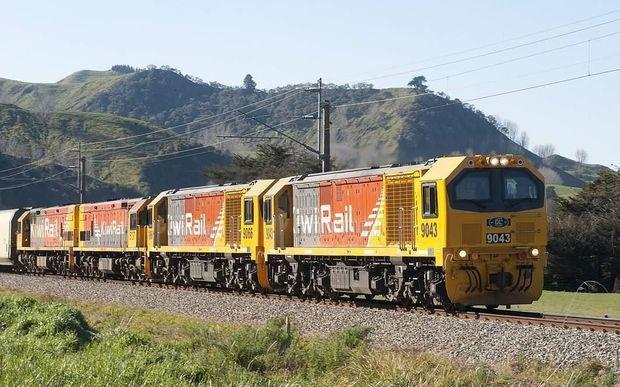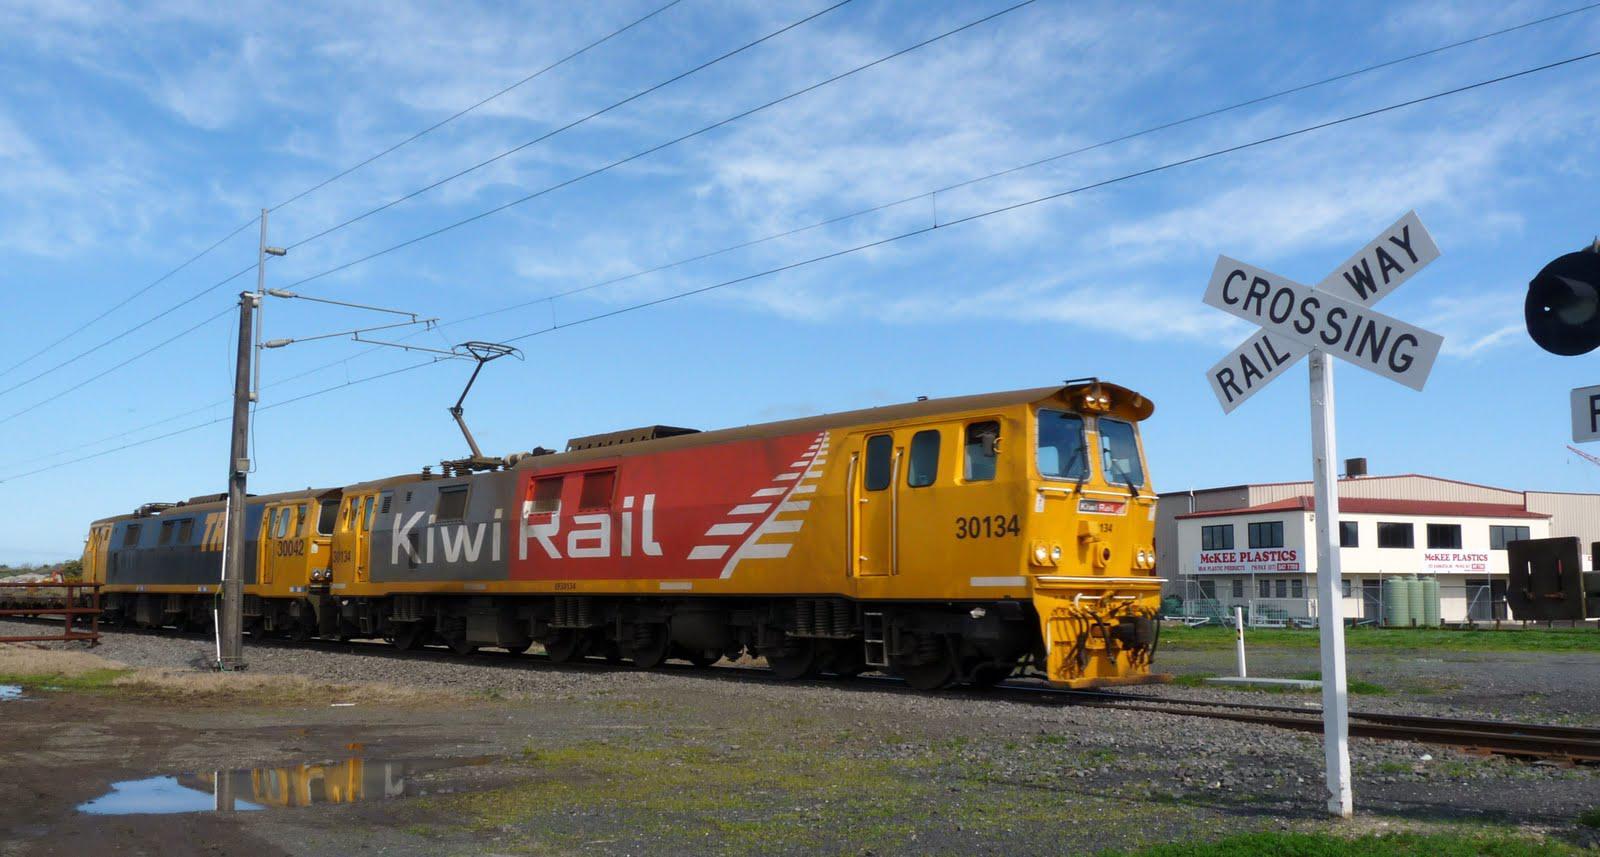The first image is the image on the left, the second image is the image on the right. For the images displayed, is the sentence "At least one electric pole is by a train track." factually correct? Answer yes or no. Yes. 